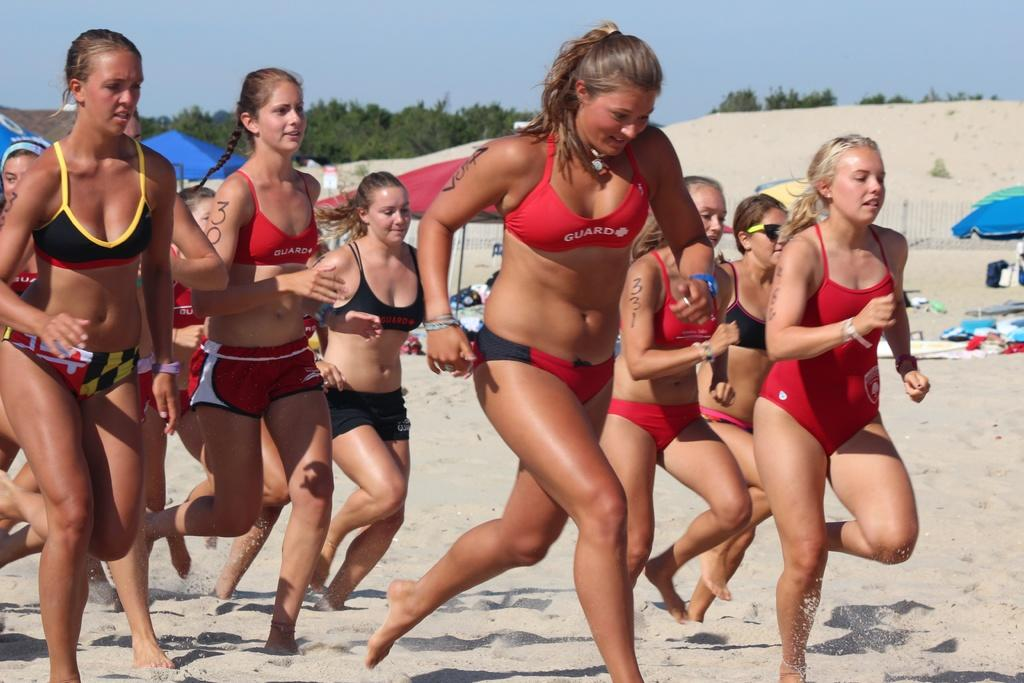<image>
Give a short and clear explanation of the subsequent image. A girl in a red guard swimsuit runs on the beach with other girls. 